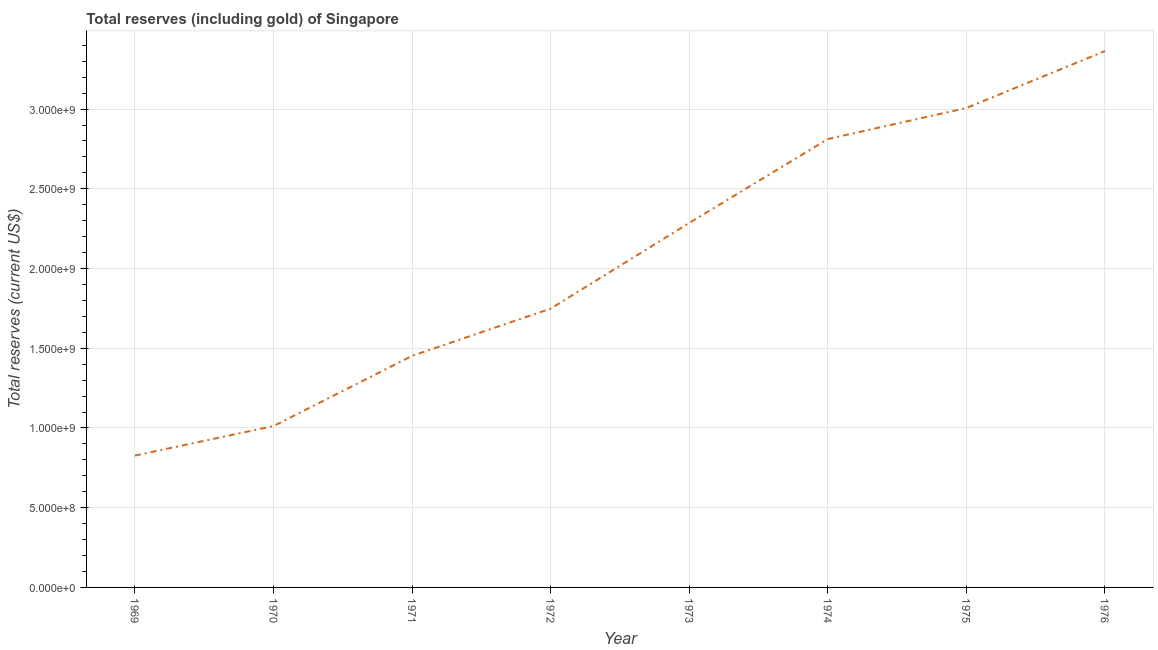What is the total reserves (including gold) in 1974?
Offer a terse response. 2.81e+09. Across all years, what is the maximum total reserves (including gold)?
Give a very brief answer. 3.36e+09. Across all years, what is the minimum total reserves (including gold)?
Make the answer very short. 8.27e+08. In which year was the total reserves (including gold) maximum?
Your answer should be compact. 1976. In which year was the total reserves (including gold) minimum?
Ensure brevity in your answer.  1969. What is the sum of the total reserves (including gold)?
Ensure brevity in your answer.  1.65e+1. What is the difference between the total reserves (including gold) in 1971 and 1974?
Offer a terse response. -1.36e+09. What is the average total reserves (including gold) per year?
Keep it short and to the point. 2.06e+09. What is the median total reserves (including gold)?
Offer a very short reply. 2.02e+09. In how many years, is the total reserves (including gold) greater than 3100000000 US$?
Give a very brief answer. 1. Do a majority of the years between 1974 and 1976 (inclusive) have total reserves (including gold) greater than 2300000000 US$?
Provide a short and direct response. Yes. What is the ratio of the total reserves (including gold) in 1970 to that in 1975?
Provide a succinct answer. 0.34. Is the difference between the total reserves (including gold) in 1969 and 1972 greater than the difference between any two years?
Keep it short and to the point. No. What is the difference between the highest and the second highest total reserves (including gold)?
Your answer should be very brief. 3.57e+08. Is the sum of the total reserves (including gold) in 1969 and 1972 greater than the maximum total reserves (including gold) across all years?
Provide a short and direct response. No. What is the difference between the highest and the lowest total reserves (including gold)?
Offer a terse response. 2.54e+09. In how many years, is the total reserves (including gold) greater than the average total reserves (including gold) taken over all years?
Give a very brief answer. 4. Does the total reserves (including gold) monotonically increase over the years?
Keep it short and to the point. Yes. How many years are there in the graph?
Your response must be concise. 8. What is the difference between two consecutive major ticks on the Y-axis?
Your response must be concise. 5.00e+08. Are the values on the major ticks of Y-axis written in scientific E-notation?
Your answer should be very brief. Yes. Does the graph contain grids?
Provide a short and direct response. Yes. What is the title of the graph?
Ensure brevity in your answer.  Total reserves (including gold) of Singapore. What is the label or title of the X-axis?
Offer a very short reply. Year. What is the label or title of the Y-axis?
Your response must be concise. Total reserves (current US$). What is the Total reserves (current US$) of 1969?
Your answer should be compact. 8.27e+08. What is the Total reserves (current US$) in 1970?
Your answer should be very brief. 1.01e+09. What is the Total reserves (current US$) in 1971?
Keep it short and to the point. 1.45e+09. What is the Total reserves (current US$) in 1972?
Your answer should be compact. 1.75e+09. What is the Total reserves (current US$) in 1973?
Provide a succinct answer. 2.29e+09. What is the Total reserves (current US$) in 1974?
Your answer should be very brief. 2.81e+09. What is the Total reserves (current US$) in 1975?
Give a very brief answer. 3.01e+09. What is the Total reserves (current US$) of 1976?
Provide a short and direct response. 3.36e+09. What is the difference between the Total reserves (current US$) in 1969 and 1970?
Offer a terse response. -1.85e+08. What is the difference between the Total reserves (current US$) in 1969 and 1971?
Offer a very short reply. -6.26e+08. What is the difference between the Total reserves (current US$) in 1969 and 1972?
Keep it short and to the point. -9.22e+08. What is the difference between the Total reserves (current US$) in 1969 and 1973?
Your answer should be very brief. -1.46e+09. What is the difference between the Total reserves (current US$) in 1969 and 1974?
Offer a very short reply. -1.99e+09. What is the difference between the Total reserves (current US$) in 1969 and 1975?
Ensure brevity in your answer.  -2.18e+09. What is the difference between the Total reserves (current US$) in 1969 and 1976?
Ensure brevity in your answer.  -2.54e+09. What is the difference between the Total reserves (current US$) in 1970 and 1971?
Make the answer very short. -4.40e+08. What is the difference between the Total reserves (current US$) in 1970 and 1972?
Provide a succinct answer. -7.36e+08. What is the difference between the Total reserves (current US$) in 1970 and 1973?
Provide a short and direct response. -1.27e+09. What is the difference between the Total reserves (current US$) in 1970 and 1974?
Keep it short and to the point. -1.80e+09. What is the difference between the Total reserves (current US$) in 1970 and 1975?
Your response must be concise. -1.99e+09. What is the difference between the Total reserves (current US$) in 1970 and 1976?
Provide a succinct answer. -2.35e+09. What is the difference between the Total reserves (current US$) in 1971 and 1972?
Offer a terse response. -2.96e+08. What is the difference between the Total reserves (current US$) in 1971 and 1973?
Your answer should be very brief. -8.33e+08. What is the difference between the Total reserves (current US$) in 1971 and 1974?
Ensure brevity in your answer.  -1.36e+09. What is the difference between the Total reserves (current US$) in 1971 and 1975?
Keep it short and to the point. -1.55e+09. What is the difference between the Total reserves (current US$) in 1971 and 1976?
Ensure brevity in your answer.  -1.91e+09. What is the difference between the Total reserves (current US$) in 1972 and 1973?
Offer a very short reply. -5.37e+08. What is the difference between the Total reserves (current US$) in 1972 and 1974?
Provide a short and direct response. -1.06e+09. What is the difference between the Total reserves (current US$) in 1972 and 1975?
Offer a terse response. -1.26e+09. What is the difference between the Total reserves (current US$) in 1972 and 1976?
Your response must be concise. -1.62e+09. What is the difference between the Total reserves (current US$) in 1973 and 1974?
Your answer should be compact. -5.26e+08. What is the difference between the Total reserves (current US$) in 1973 and 1975?
Your answer should be very brief. -7.21e+08. What is the difference between the Total reserves (current US$) in 1973 and 1976?
Provide a succinct answer. -1.08e+09. What is the difference between the Total reserves (current US$) in 1974 and 1975?
Your answer should be compact. -1.95e+08. What is the difference between the Total reserves (current US$) in 1974 and 1976?
Provide a short and direct response. -5.52e+08. What is the difference between the Total reserves (current US$) in 1975 and 1976?
Offer a very short reply. -3.57e+08. What is the ratio of the Total reserves (current US$) in 1969 to that in 1970?
Offer a very short reply. 0.82. What is the ratio of the Total reserves (current US$) in 1969 to that in 1971?
Your answer should be compact. 0.57. What is the ratio of the Total reserves (current US$) in 1969 to that in 1972?
Your answer should be compact. 0.47. What is the ratio of the Total reserves (current US$) in 1969 to that in 1973?
Make the answer very short. 0.36. What is the ratio of the Total reserves (current US$) in 1969 to that in 1974?
Make the answer very short. 0.29. What is the ratio of the Total reserves (current US$) in 1969 to that in 1975?
Offer a very short reply. 0.28. What is the ratio of the Total reserves (current US$) in 1969 to that in 1976?
Your answer should be compact. 0.25. What is the ratio of the Total reserves (current US$) in 1970 to that in 1971?
Offer a very short reply. 0.7. What is the ratio of the Total reserves (current US$) in 1970 to that in 1972?
Provide a short and direct response. 0.58. What is the ratio of the Total reserves (current US$) in 1970 to that in 1973?
Your answer should be very brief. 0.44. What is the ratio of the Total reserves (current US$) in 1970 to that in 1974?
Provide a succinct answer. 0.36. What is the ratio of the Total reserves (current US$) in 1970 to that in 1975?
Provide a short and direct response. 0.34. What is the ratio of the Total reserves (current US$) in 1970 to that in 1976?
Offer a terse response. 0.3. What is the ratio of the Total reserves (current US$) in 1971 to that in 1972?
Keep it short and to the point. 0.83. What is the ratio of the Total reserves (current US$) in 1971 to that in 1973?
Your answer should be very brief. 0.64. What is the ratio of the Total reserves (current US$) in 1971 to that in 1974?
Ensure brevity in your answer.  0.52. What is the ratio of the Total reserves (current US$) in 1971 to that in 1975?
Your response must be concise. 0.48. What is the ratio of the Total reserves (current US$) in 1971 to that in 1976?
Provide a short and direct response. 0.43. What is the ratio of the Total reserves (current US$) in 1972 to that in 1973?
Keep it short and to the point. 0.77. What is the ratio of the Total reserves (current US$) in 1972 to that in 1974?
Provide a short and direct response. 0.62. What is the ratio of the Total reserves (current US$) in 1972 to that in 1975?
Provide a short and direct response. 0.58. What is the ratio of the Total reserves (current US$) in 1972 to that in 1976?
Offer a terse response. 0.52. What is the ratio of the Total reserves (current US$) in 1973 to that in 1974?
Your answer should be very brief. 0.81. What is the ratio of the Total reserves (current US$) in 1973 to that in 1975?
Keep it short and to the point. 0.76. What is the ratio of the Total reserves (current US$) in 1973 to that in 1976?
Provide a succinct answer. 0.68. What is the ratio of the Total reserves (current US$) in 1974 to that in 1975?
Your answer should be very brief. 0.94. What is the ratio of the Total reserves (current US$) in 1974 to that in 1976?
Offer a terse response. 0.84. What is the ratio of the Total reserves (current US$) in 1975 to that in 1976?
Ensure brevity in your answer.  0.89. 